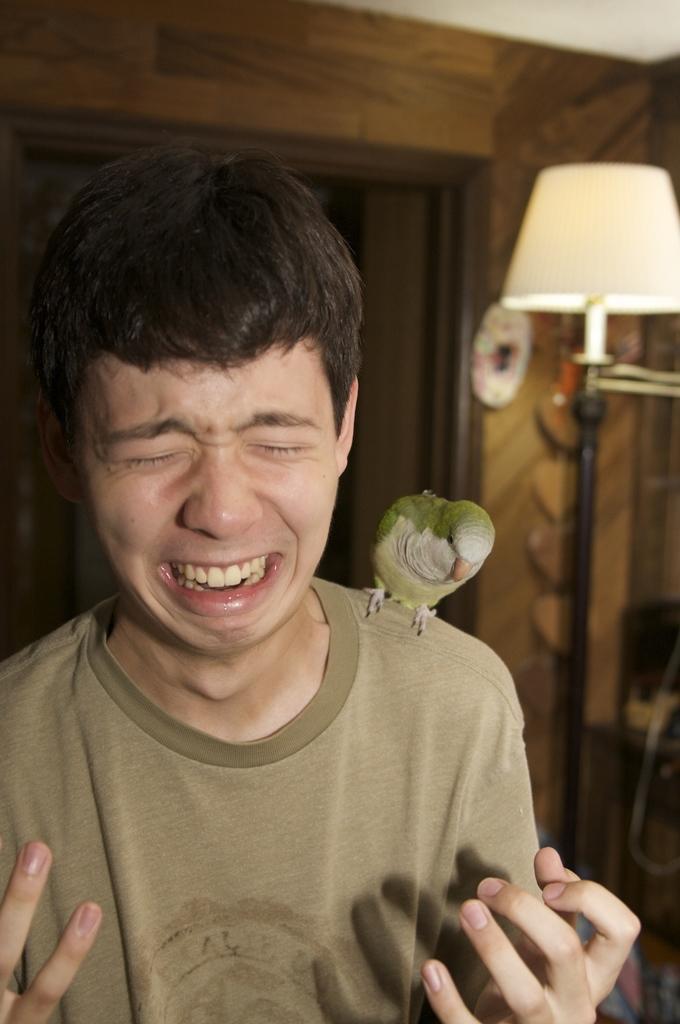Describe this image in one or two sentences. In the middle of the image a person is standing and crying, on his shoulder there is a bird. Behind him there is wall and lamp. 